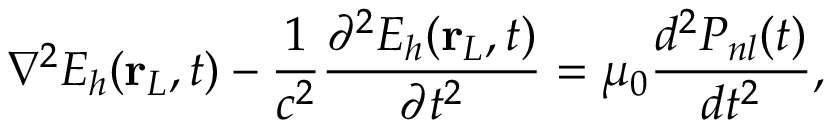Convert formula to latex. <formula><loc_0><loc_0><loc_500><loc_500>\nabla ^ { 2 } E _ { h } ( r _ { L } , t ) - \frac { 1 } { c ^ { 2 } } \frac { \partial ^ { 2 } E _ { h } ( r _ { L } , t ) } { \partial t ^ { 2 } } = \mu _ { 0 } \frac { d ^ { 2 } P _ { n l } ( t ) } { d t ^ { 2 } } ,</formula> 